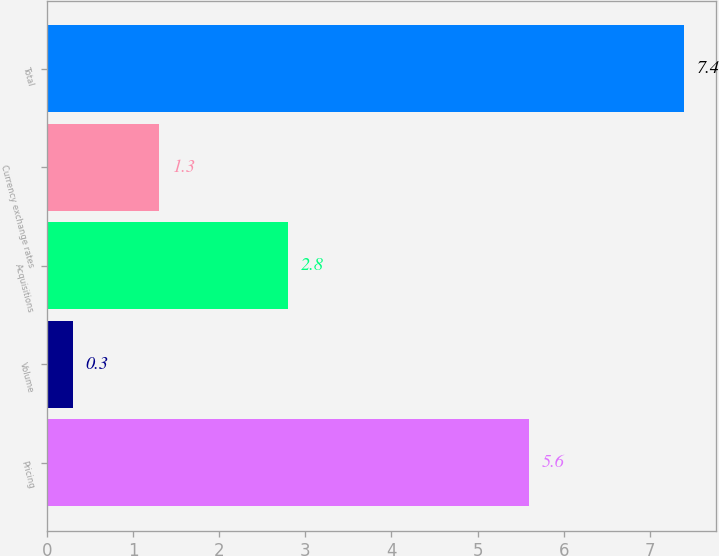Convert chart to OTSL. <chart><loc_0><loc_0><loc_500><loc_500><bar_chart><fcel>Pricing<fcel>Volume<fcel>Acquisitions<fcel>Currency exchange rates<fcel>Total<nl><fcel>5.6<fcel>0.3<fcel>2.8<fcel>1.3<fcel>7.4<nl></chart> 